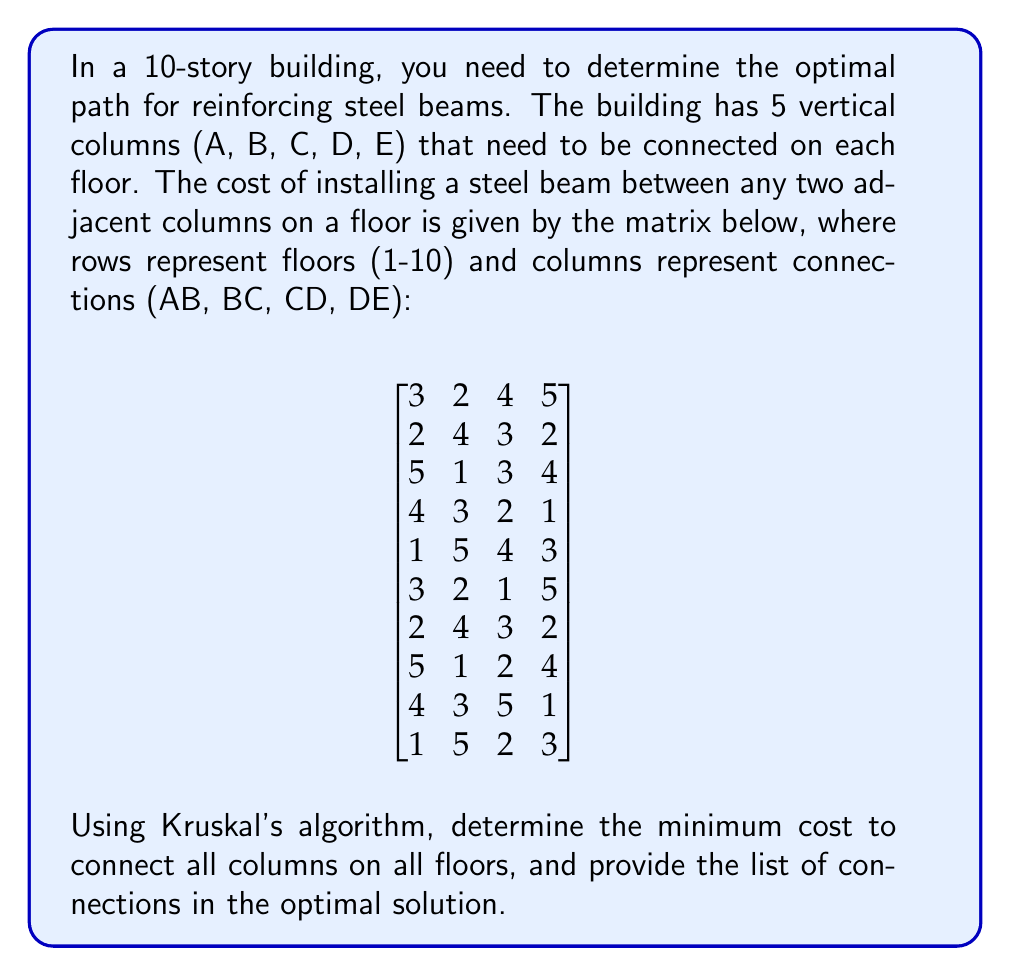Teach me how to tackle this problem. To solve this problem, we'll use Kruskal's algorithm to find the Minimum Spanning Tree (MST) for each floor independently, then sum up the total cost.

Kruskal's algorithm steps:
1. Sort all edges by weight (cost) in ascending order.
2. Start with an empty set of edges.
3. For each edge, if it doesn't form a cycle with the already selected edges, add it to the solution.
4. Repeat step 3 until we have $n-1$ edges, where $n$ is the number of vertices.

For each floor:
1. We have 5 vertices (A, B, C, D, E) and need 4 edges to connect them all.
2. Sort the 4 given edges by cost.
3. Select the cheapest edges that don't form cycles.

Let's apply this to each floor:

Floor 1: Sorted edges: BC(2), AB(3), CD(4), DE(5). MST: BC, AB, CD. Cost: 2+3+4 = 9
Floor 2: Sorted edges: AB(2), DE(2), CD(3), BC(4). MST: AB, DE, CD. Cost: 2+2+3 = 7
Floor 3: Sorted edges: BC(1), CD(3), DE(4), AB(5). MST: BC, CD, DE. Cost: 1+3+4 = 8
Floor 4: Sorted edges: DE(1), CD(2), BC(3), AB(4). MST: DE, CD, BC. Cost: 1+2+3 = 6
Floor 5: Sorted edges: AB(1), DE(3), CD(4), BC(5). MST: AB, DE, CD. Cost: 1+3+4 = 8
Floor 6: Sorted edges: CD(1), BC(2), AB(3), DE(5). MST: CD, BC, AB. Cost: 1+2+3 = 6
Floor 7: Sorted edges: AB(2), DE(2), CD(3), BC(4). MST: AB, DE, CD. Cost: 2+2+3 = 7
Floor 8: Sorted edges: BC(1), CD(2), DE(4), AB(5). MST: BC, CD, DE. Cost: 1+2+4 = 7
Floor 9: Sorted edges: DE(1), BC(3), AB(4), CD(5). MST: DE, BC, AB. Cost: 1+3+4 = 8
Floor 10: Sorted edges: AB(1), CD(2), DE(3), BC(5). MST: AB, CD, DE. Cost: 1+2+3 = 6

The total minimum cost is the sum of all floor costs: 9+7+8+6+8+6+7+7+8+6 = 72

The optimal solution includes the following connections:
Floor 1: BC, AB, CD
Floor 2: AB, DE, CD
Floor 3: BC, CD, DE
Floor 4: DE, CD, BC
Floor 5: AB, DE, CD
Floor 6: CD, BC, AB
Floor 7: AB, DE, CD
Floor 8: BC, CD, DE
Floor 9: DE, BC, AB
Floor 10: AB, CD, DE
Answer: The minimum cost to connect all columns on all floors is $72. The optimal solution includes 30 connections, as listed in the explanation. 